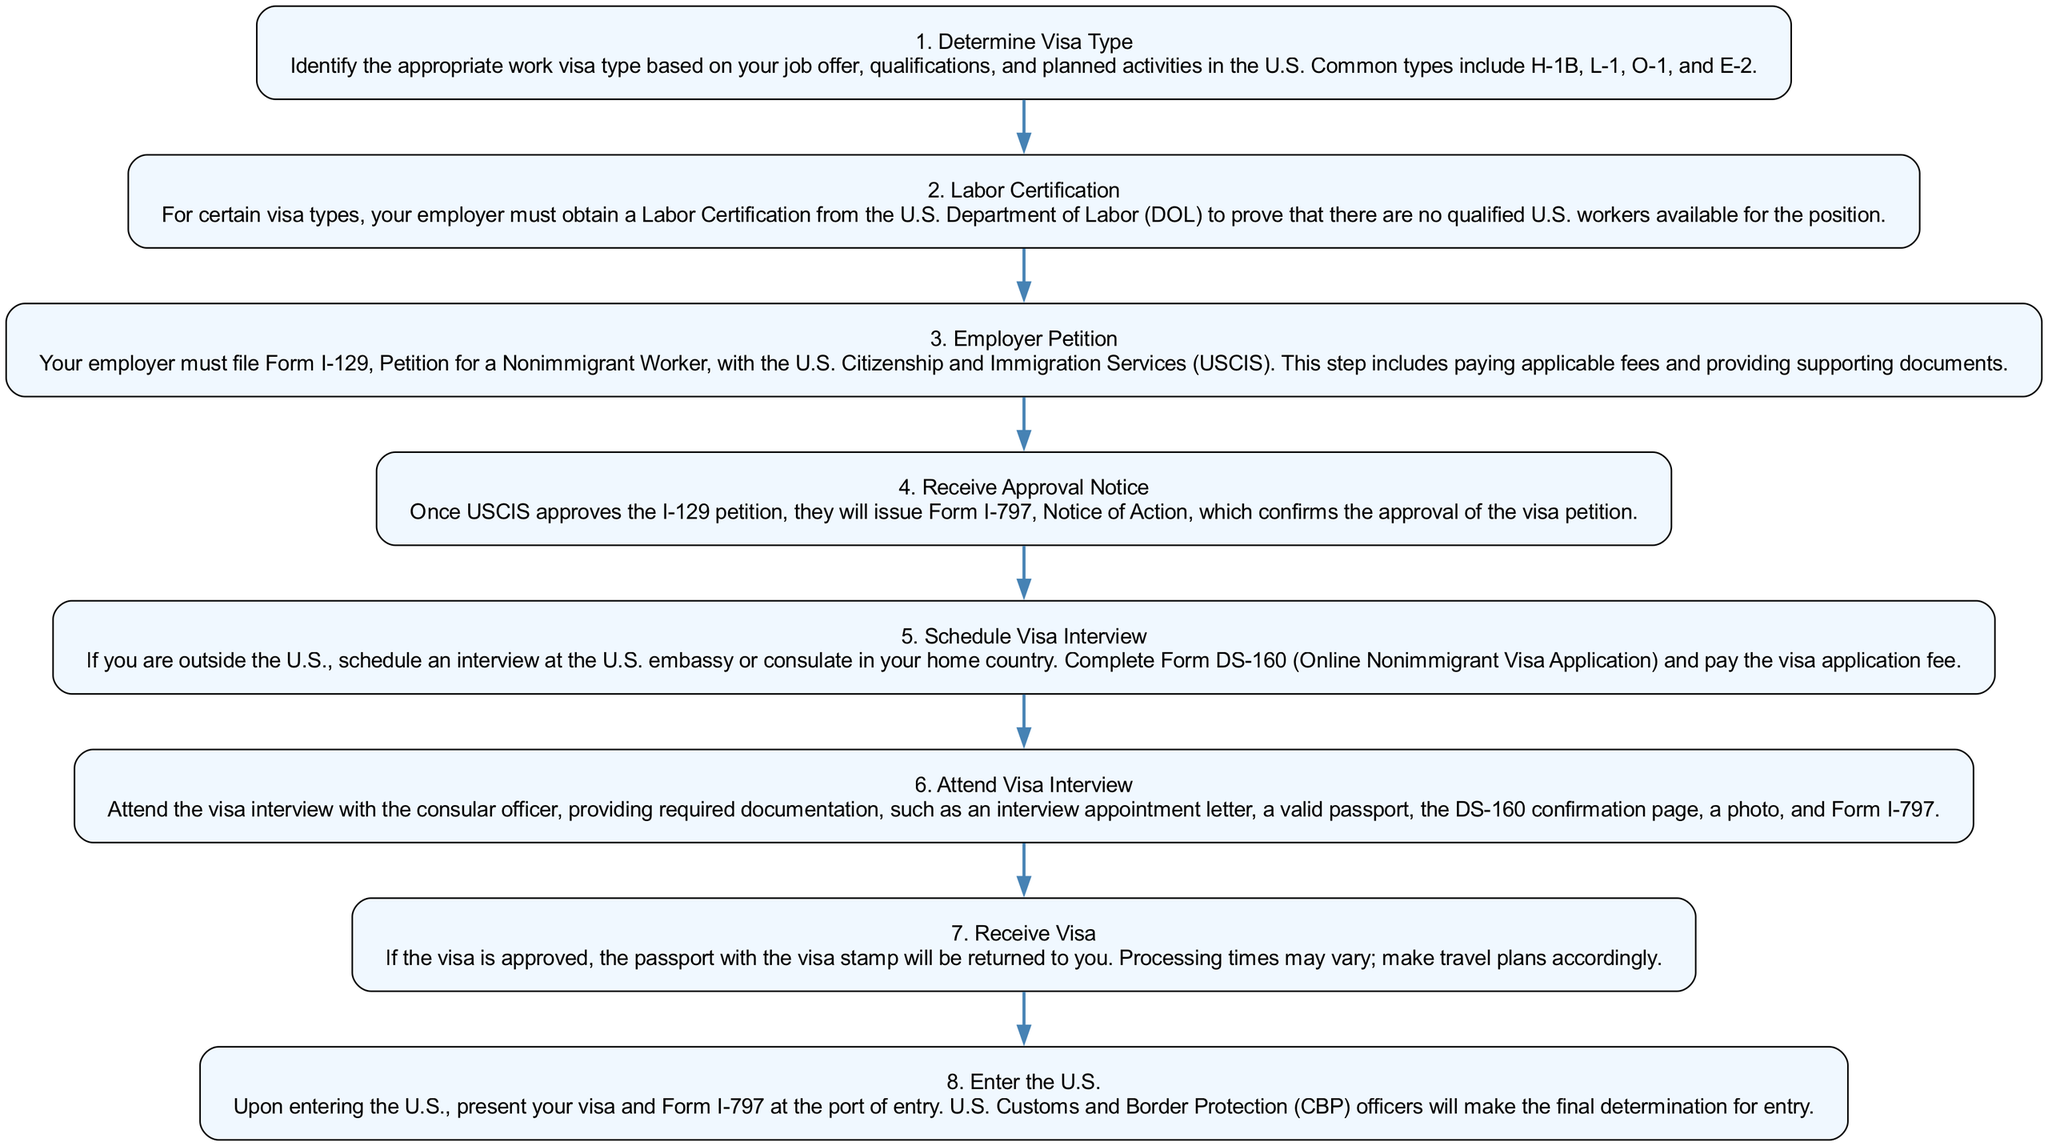What is the first step in the visa application process? The first step listed in the diagram is "Determine Visa Type," which involves identifying the appropriate visa based on job offer and qualifications.
Answer: Determine Visa Type How many steps are there in the diagram? By counting all the listed steps in the diagram, there are a total of 8 steps from determining the visa type to entering the U.S.
Answer: 8 What document does the employer need to file for the petition? The employer is required to file Form I-129 as indicated in the "Employer Petition" step.
Answer: Form I-129 What happens after receiving the approval notice? After receiving the approval notice, the next step is to "Schedule Visa Interview" according to the diagram flow.
Answer: Schedule Visa Interview Which step requires attending an interview? "Attend Visa Interview" is the step that explicitly mentions the need for the applicant to attend an interview with a consular officer.
Answer: Attend Visa Interview What is required to enter the U.S.? To enter the U.S., one must present the visa and Form I-797 at the port of entry, as outlined in the final step of the diagram.
Answer: Visa and Form I-797 What is the purpose of the Labor Certification? The Labor Certification is required to prove that there are no qualified U.S. workers available for the position, as specified in the second step.
Answer: Prove no qualified U.S. workers Which step directly follows the employer petition step? "Receive Approval Notice" directly follows the "Employer Petition" step in the flow of the process.
Answer: Receive Approval Notice What form must be completed for the visa application? Form DS-160 must be completed for the visa application, as stated in the "Schedule Visa Interview" step.
Answer: Form DS-160 